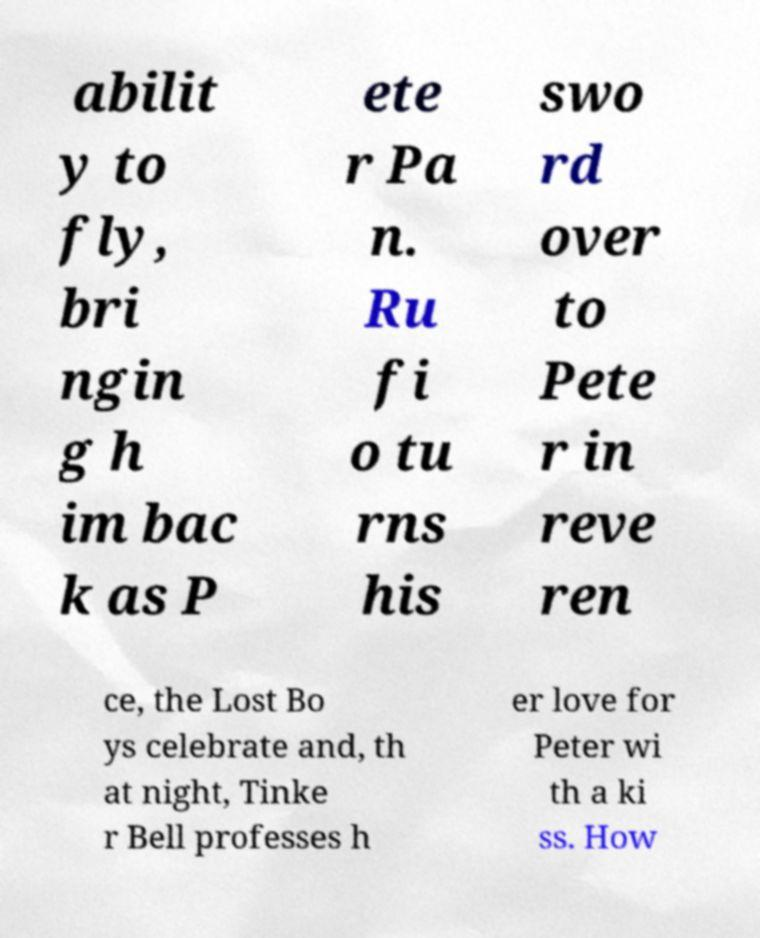I need the written content from this picture converted into text. Can you do that? abilit y to fly, bri ngin g h im bac k as P ete r Pa n. Ru fi o tu rns his swo rd over to Pete r in reve ren ce, the Lost Bo ys celebrate and, th at night, Tinke r Bell professes h er love for Peter wi th a ki ss. How 